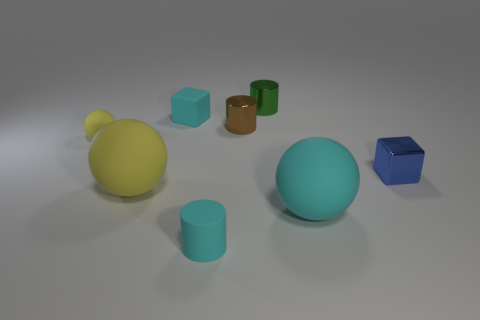Subtract all tiny green metal cylinders. How many cylinders are left? 2 Add 1 purple rubber spheres. How many objects exist? 9 Subtract all cyan blocks. How many blocks are left? 1 Subtract all yellow cubes. How many yellow balls are left? 2 Subtract 2 cubes. How many cubes are left? 0 Subtract all red balls. Subtract all yellow cylinders. How many balls are left? 3 Subtract all blue metallic blocks. Subtract all small matte cylinders. How many objects are left? 6 Add 4 big yellow things. How many big yellow things are left? 5 Add 2 big red spheres. How many big red spheres exist? 2 Subtract 1 green cylinders. How many objects are left? 7 